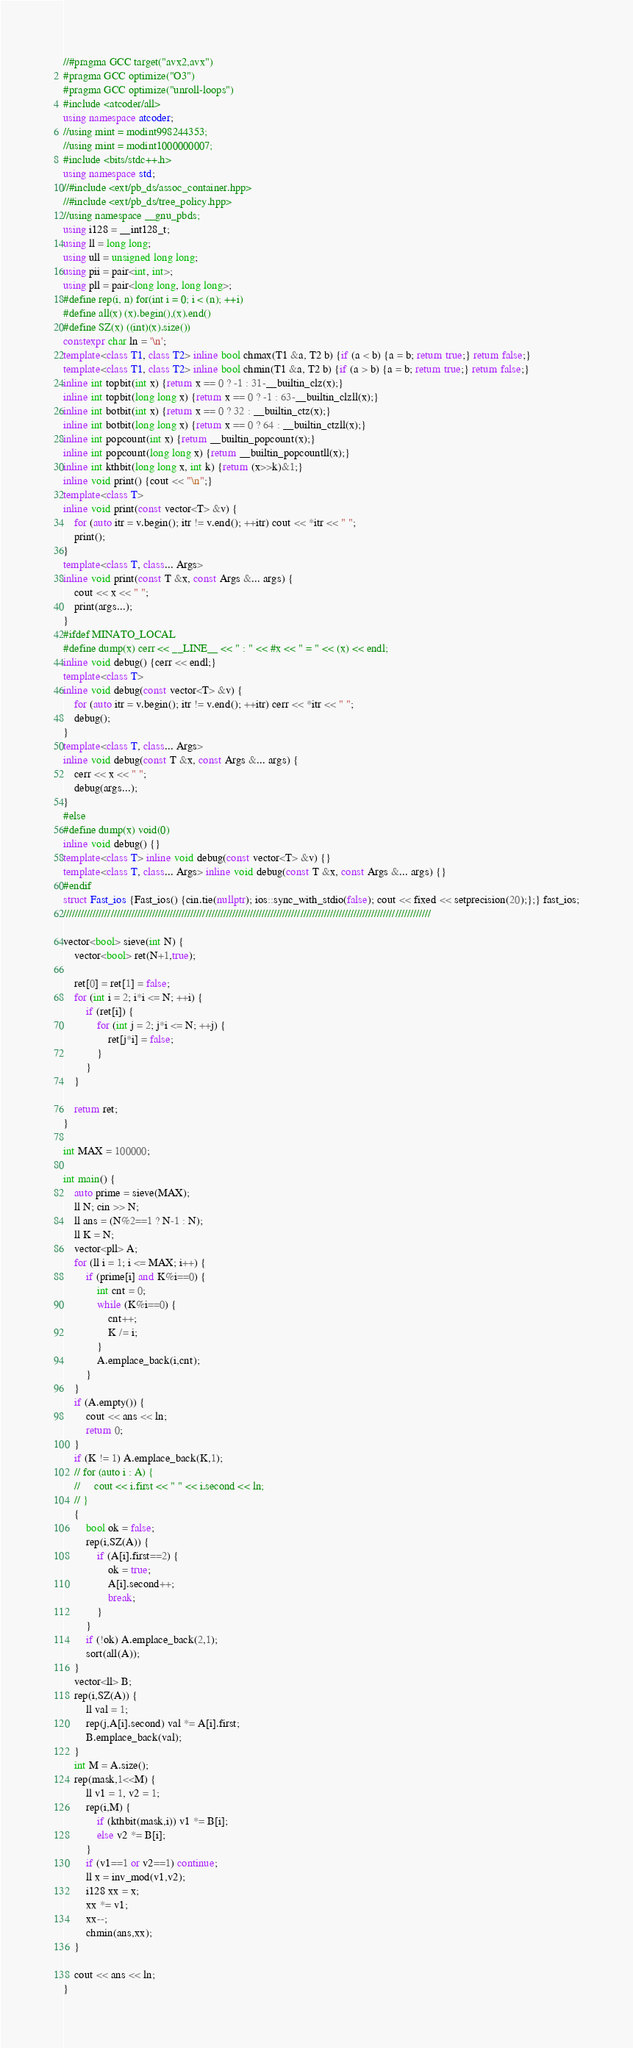<code> <loc_0><loc_0><loc_500><loc_500><_C++_>//#pragma GCC target("avx2,avx")
#pragma GCC optimize("O3")
#pragma GCC optimize("unroll-loops")
#include <atcoder/all>
using namespace atcoder;
//using mint = modint998244353;
//using mint = modint1000000007;
#include <bits/stdc++.h>
using namespace std;
//#include <ext/pb_ds/assoc_container.hpp>
//#include <ext/pb_ds/tree_policy.hpp>
//using namespace __gnu_pbds;
using i128 = __int128_t;
using ll = long long;
using ull = unsigned long long;
using pii = pair<int, int>;
using pll = pair<long long, long long>;
#define rep(i, n) for(int i = 0; i < (n); ++i)
#define all(x) (x).begin(),(x).end()
#define SZ(x) ((int)(x).size())
constexpr char ln = '\n';
template<class T1, class T2> inline bool chmax(T1 &a, T2 b) {if (a < b) {a = b; return true;} return false;}
template<class T1, class T2> inline bool chmin(T1 &a, T2 b) {if (a > b) {a = b; return true;} return false;}
inline int topbit(int x) {return x == 0 ? -1 : 31-__builtin_clz(x);}
inline int topbit(long long x) {return x == 0 ? -1 : 63-__builtin_clzll(x);}
inline int botbit(int x) {return x == 0 ? 32 : __builtin_ctz(x);}
inline int botbit(long long x) {return x == 0 ? 64 : __builtin_ctzll(x);}
inline int popcount(int x) {return __builtin_popcount(x);}
inline int popcount(long long x) {return __builtin_popcountll(x);}
inline int kthbit(long long x, int k) {return (x>>k)&1;}
inline void print() {cout << "\n";}
template<class T>
inline void print(const vector<T> &v) {
    for (auto itr = v.begin(); itr != v.end(); ++itr) cout << *itr << " ";
    print();
}
template<class T, class... Args>
inline void print(const T &x, const Args &... args) {
    cout << x << " ";
    print(args...);
}
#ifdef MINATO_LOCAL
#define dump(x) cerr << __LINE__ << " : " << #x << " = " << (x) << endl;
inline void debug() {cerr << endl;}
template<class T>
inline void debug(const vector<T> &v) {
    for (auto itr = v.begin(); itr != v.end(); ++itr) cerr << *itr << " ";
    debug();
}
template<class T, class... Args>
inline void debug(const T &x, const Args &... args) {
    cerr << x << " ";
    debug(args...);
}
#else
#define dump(x) void(0)
inline void debug() {}
template<class T> inline void debug(const vector<T> &v) {}
template<class T, class... Args> inline void debug(const T &x, const Args &... args) {}
#endif
struct Fast_ios {Fast_ios() {cin.tie(nullptr); ios::sync_with_stdio(false); cout << fixed << setprecision(20);};} fast_ios;
////////////////////////////////////////////////////////////////////////////////////////////////////////////////////////////

vector<bool> sieve(int N) {
    vector<bool> ret(N+1,true);
    
    ret[0] = ret[1] = false;
    for (int i = 2; i*i <= N; ++i) {
        if (ret[i]) {
            for (int j = 2; j*i <= N; ++j) {
                ret[j*i] = false;
            }
        }
    }

    return ret;
}

int MAX = 100000;

int main() {
    auto prime = sieve(MAX);
    ll N; cin >> N;
    ll ans = (N%2==1 ? N-1 : N);
    ll K = N;
    vector<pll> A;
    for (ll i = 1; i <= MAX; i++) {
        if (prime[i] and K%i==0) {
            int cnt = 0;
            while (K%i==0) {
                cnt++;
                K /= i;
            }
            A.emplace_back(i,cnt);
        }
    }
    if (A.empty()) {
        cout << ans << ln;
        return 0;
    }
    if (K != 1) A.emplace_back(K,1);
    // for (auto i : A) {
    //     cout << i.first << " " << i.second << ln;
    // }
    {
        bool ok = false;
        rep(i,SZ(A)) {
            if (A[i].first==2) {
                ok = true;
                A[i].second++;
                break;
            }
        }
        if (!ok) A.emplace_back(2,1);
        sort(all(A));
    }
    vector<ll> B;
    rep(i,SZ(A)) {
        ll val = 1;
        rep(j,A[i].second) val *= A[i].first;
        B.emplace_back(val);
    }
    int M = A.size();
    rep(mask,1<<M) {
        ll v1 = 1, v2 = 1;
        rep(i,M) {
            if (kthbit(mask,i)) v1 *= B[i];
            else v2 *= B[i];  
        }
        if (v1==1 or v2==1) continue;
        ll x = inv_mod(v1,v2);
        i128 xx = x;
        xx *= v1;
        xx--;
        chmin(ans,xx);
    }

    cout << ans << ln;
}
</code> 